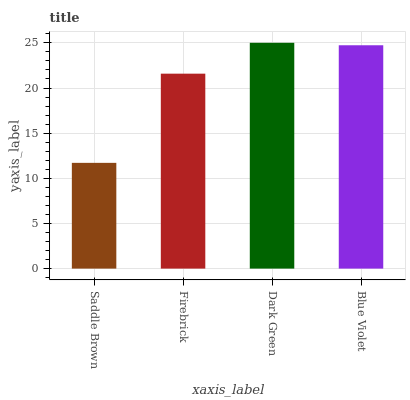Is Saddle Brown the minimum?
Answer yes or no. Yes. Is Dark Green the maximum?
Answer yes or no. Yes. Is Firebrick the minimum?
Answer yes or no. No. Is Firebrick the maximum?
Answer yes or no. No. Is Firebrick greater than Saddle Brown?
Answer yes or no. Yes. Is Saddle Brown less than Firebrick?
Answer yes or no. Yes. Is Saddle Brown greater than Firebrick?
Answer yes or no. No. Is Firebrick less than Saddle Brown?
Answer yes or no. No. Is Blue Violet the high median?
Answer yes or no. Yes. Is Firebrick the low median?
Answer yes or no. Yes. Is Dark Green the high median?
Answer yes or no. No. Is Blue Violet the low median?
Answer yes or no. No. 